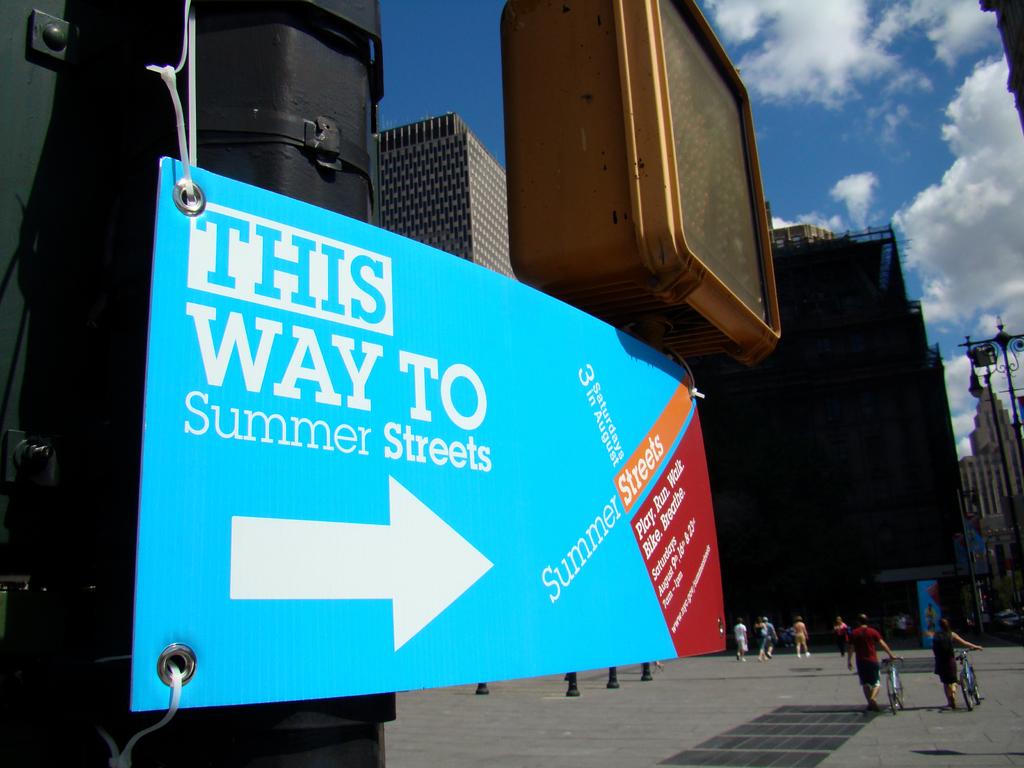This way to where?
Make the answer very short. Summer streets. 